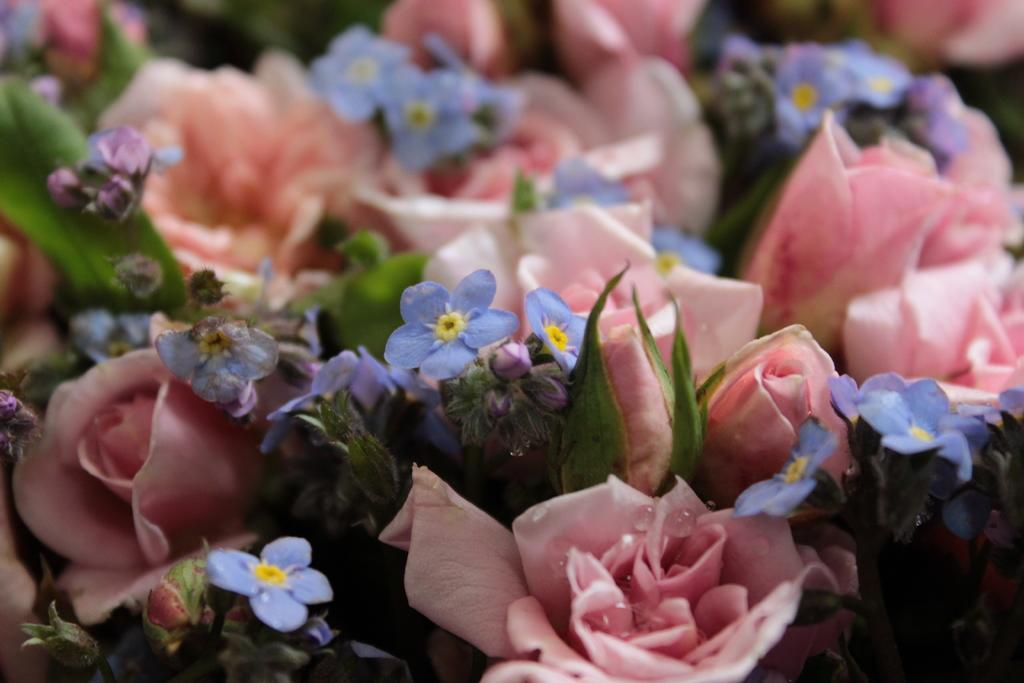What types of flowers can be seen in the image? There are many flowers in the image, and they are in pink, yellow, and blue colors. What other elements can be seen in the image besides flowers? There are leaves in the image, and they are in green color. How would you describe the background of the image? The background of the image is blurred. Can you see any hooks in the image? There are no hooks present in the image. What is the elbow's role in the image? There is no elbow present in the image, so it does not have a role. 